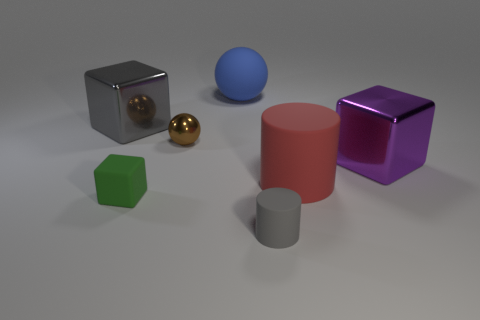Subtract all big gray metallic cubes. How many cubes are left? 2 Subtract all gray spheres. Subtract all blue cylinders. How many spheres are left? 2 Subtract all brown cylinders. How many blue spheres are left? 1 Subtract all brown balls. How many balls are left? 1 Subtract 0 brown cubes. How many objects are left? 7 Subtract all balls. How many objects are left? 5 Subtract 1 spheres. How many spheres are left? 1 Subtract all large blue matte cylinders. Subtract all small brown spheres. How many objects are left? 6 Add 2 brown metallic objects. How many brown metallic objects are left? 3 Add 4 tiny brown shiny things. How many tiny brown shiny things exist? 5 